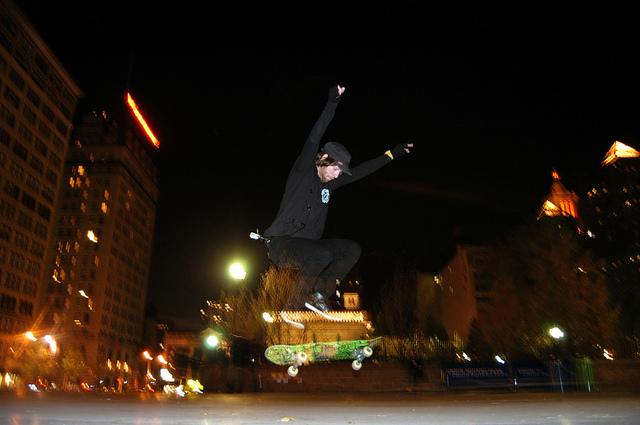Is think so?
Be succinct. No. Is this night time?
Be succinct. Yes. Is he enjoying this activity?
Write a very short answer. Yes. 